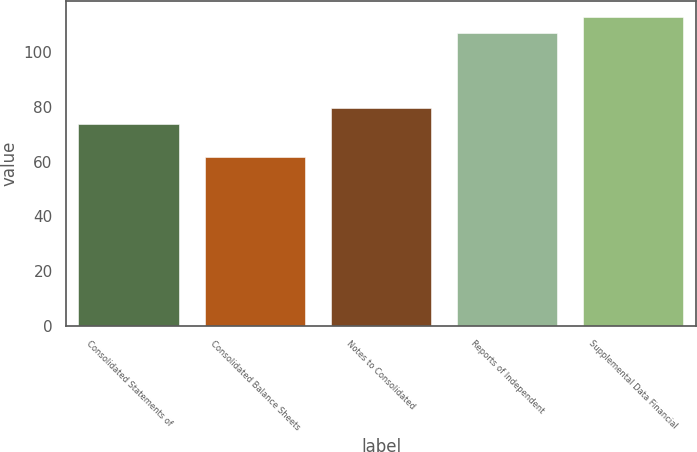<chart> <loc_0><loc_0><loc_500><loc_500><bar_chart><fcel>Consolidated Statements of<fcel>Consolidated Balance Sheets<fcel>Notes to Consolidated<fcel>Reports of Independent<fcel>Supplemental Data Financial<nl><fcel>73.6<fcel>61.8<fcel>79.5<fcel>107<fcel>112.9<nl></chart> 